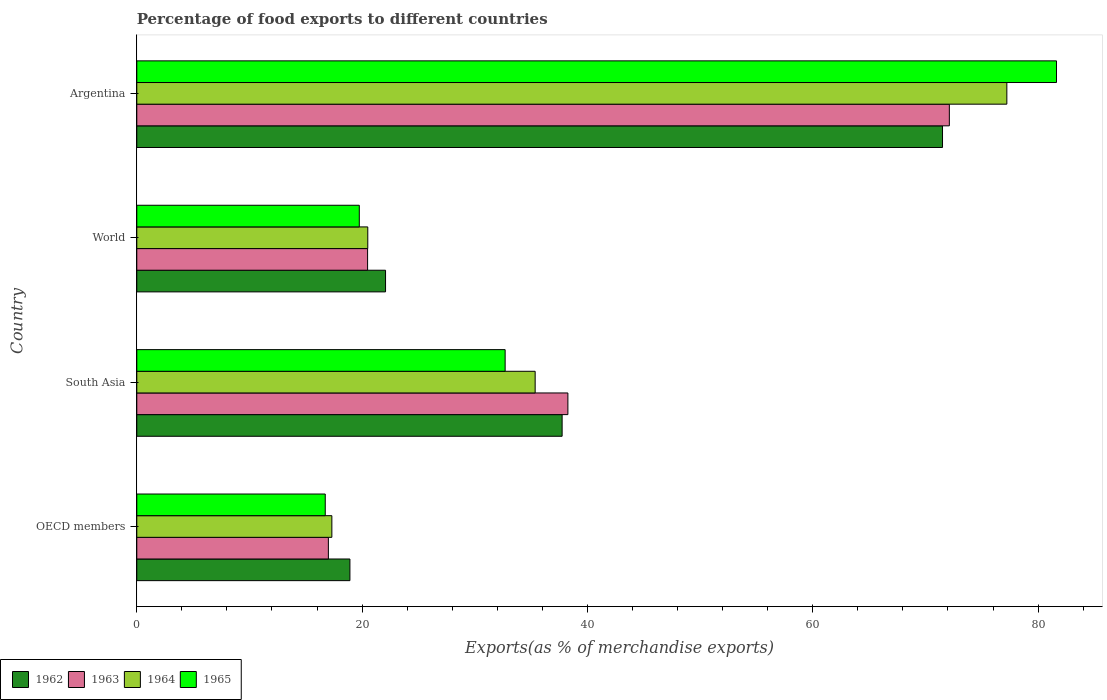Are the number of bars per tick equal to the number of legend labels?
Your response must be concise. Yes. Are the number of bars on each tick of the Y-axis equal?
Keep it short and to the point. Yes. How many bars are there on the 1st tick from the bottom?
Keep it short and to the point. 4. What is the label of the 1st group of bars from the top?
Your answer should be compact. Argentina. What is the percentage of exports to different countries in 1962 in OECD members?
Ensure brevity in your answer.  18.92. Across all countries, what is the maximum percentage of exports to different countries in 1962?
Your answer should be very brief. 71.52. Across all countries, what is the minimum percentage of exports to different countries in 1962?
Ensure brevity in your answer.  18.92. In which country was the percentage of exports to different countries in 1965 maximum?
Your answer should be compact. Argentina. In which country was the percentage of exports to different countries in 1965 minimum?
Provide a short and direct response. OECD members. What is the total percentage of exports to different countries in 1963 in the graph?
Your response must be concise. 147.88. What is the difference between the percentage of exports to different countries in 1963 in Argentina and that in OECD members?
Offer a terse response. 55.12. What is the difference between the percentage of exports to different countries in 1963 in South Asia and the percentage of exports to different countries in 1964 in World?
Make the answer very short. 17.76. What is the average percentage of exports to different countries in 1964 per country?
Provide a succinct answer. 37.6. What is the difference between the percentage of exports to different countries in 1965 and percentage of exports to different countries in 1962 in World?
Your answer should be very brief. -2.33. What is the ratio of the percentage of exports to different countries in 1962 in OECD members to that in World?
Give a very brief answer. 0.86. Is the percentage of exports to different countries in 1962 in OECD members less than that in World?
Your response must be concise. Yes. What is the difference between the highest and the second highest percentage of exports to different countries in 1962?
Provide a short and direct response. 33.76. What is the difference between the highest and the lowest percentage of exports to different countries in 1964?
Provide a short and direct response. 59.91. In how many countries, is the percentage of exports to different countries in 1964 greater than the average percentage of exports to different countries in 1964 taken over all countries?
Provide a short and direct response. 1. Is the sum of the percentage of exports to different countries in 1965 in Argentina and World greater than the maximum percentage of exports to different countries in 1964 across all countries?
Offer a terse response. Yes. What does the 2nd bar from the top in Argentina represents?
Provide a short and direct response. 1964. What does the 4th bar from the bottom in World represents?
Offer a terse response. 1965. Are all the bars in the graph horizontal?
Your answer should be compact. Yes. What is the difference between two consecutive major ticks on the X-axis?
Offer a terse response. 20. Are the values on the major ticks of X-axis written in scientific E-notation?
Make the answer very short. No. Does the graph contain any zero values?
Offer a very short reply. No. Does the graph contain grids?
Give a very brief answer. No. How many legend labels are there?
Your answer should be very brief. 4. How are the legend labels stacked?
Your answer should be compact. Horizontal. What is the title of the graph?
Offer a very short reply. Percentage of food exports to different countries. What is the label or title of the X-axis?
Offer a terse response. Exports(as % of merchandise exports). What is the label or title of the Y-axis?
Provide a short and direct response. Country. What is the Exports(as % of merchandise exports) in 1962 in OECD members?
Make the answer very short. 18.92. What is the Exports(as % of merchandise exports) of 1963 in OECD members?
Provide a short and direct response. 17.01. What is the Exports(as % of merchandise exports) in 1964 in OECD members?
Give a very brief answer. 17.31. What is the Exports(as % of merchandise exports) of 1965 in OECD members?
Provide a succinct answer. 16.73. What is the Exports(as % of merchandise exports) in 1962 in South Asia?
Give a very brief answer. 37.75. What is the Exports(as % of merchandise exports) of 1963 in South Asia?
Offer a terse response. 38.26. What is the Exports(as % of merchandise exports) in 1964 in South Asia?
Provide a succinct answer. 35.36. What is the Exports(as % of merchandise exports) of 1965 in South Asia?
Your response must be concise. 32.7. What is the Exports(as % of merchandise exports) in 1962 in World?
Offer a very short reply. 22.08. What is the Exports(as % of merchandise exports) in 1963 in World?
Your answer should be very brief. 20.49. What is the Exports(as % of merchandise exports) in 1964 in World?
Make the answer very short. 20.5. What is the Exports(as % of merchandise exports) in 1965 in World?
Provide a succinct answer. 19.75. What is the Exports(as % of merchandise exports) in 1962 in Argentina?
Provide a succinct answer. 71.52. What is the Exports(as % of merchandise exports) in 1963 in Argentina?
Keep it short and to the point. 72.12. What is the Exports(as % of merchandise exports) in 1964 in Argentina?
Keep it short and to the point. 77.23. What is the Exports(as % of merchandise exports) in 1965 in Argentina?
Give a very brief answer. 81.64. Across all countries, what is the maximum Exports(as % of merchandise exports) of 1962?
Offer a very short reply. 71.52. Across all countries, what is the maximum Exports(as % of merchandise exports) of 1963?
Provide a short and direct response. 72.12. Across all countries, what is the maximum Exports(as % of merchandise exports) in 1964?
Your response must be concise. 77.23. Across all countries, what is the maximum Exports(as % of merchandise exports) of 1965?
Your answer should be compact. 81.64. Across all countries, what is the minimum Exports(as % of merchandise exports) of 1962?
Your answer should be very brief. 18.92. Across all countries, what is the minimum Exports(as % of merchandise exports) of 1963?
Your answer should be compact. 17.01. Across all countries, what is the minimum Exports(as % of merchandise exports) of 1964?
Offer a terse response. 17.31. Across all countries, what is the minimum Exports(as % of merchandise exports) in 1965?
Your answer should be very brief. 16.73. What is the total Exports(as % of merchandise exports) of 1962 in the graph?
Keep it short and to the point. 150.27. What is the total Exports(as % of merchandise exports) of 1963 in the graph?
Keep it short and to the point. 147.88. What is the total Exports(as % of merchandise exports) of 1964 in the graph?
Your answer should be very brief. 150.4. What is the total Exports(as % of merchandise exports) of 1965 in the graph?
Make the answer very short. 150.81. What is the difference between the Exports(as % of merchandise exports) of 1962 in OECD members and that in South Asia?
Your answer should be very brief. -18.84. What is the difference between the Exports(as % of merchandise exports) in 1963 in OECD members and that in South Asia?
Keep it short and to the point. -21.26. What is the difference between the Exports(as % of merchandise exports) of 1964 in OECD members and that in South Asia?
Offer a terse response. -18.05. What is the difference between the Exports(as % of merchandise exports) in 1965 in OECD members and that in South Asia?
Offer a terse response. -15.97. What is the difference between the Exports(as % of merchandise exports) in 1962 in OECD members and that in World?
Your answer should be compact. -3.16. What is the difference between the Exports(as % of merchandise exports) in 1963 in OECD members and that in World?
Your answer should be very brief. -3.48. What is the difference between the Exports(as % of merchandise exports) in 1964 in OECD members and that in World?
Make the answer very short. -3.19. What is the difference between the Exports(as % of merchandise exports) in 1965 in OECD members and that in World?
Offer a very short reply. -3.02. What is the difference between the Exports(as % of merchandise exports) of 1962 in OECD members and that in Argentina?
Offer a very short reply. -52.6. What is the difference between the Exports(as % of merchandise exports) of 1963 in OECD members and that in Argentina?
Make the answer very short. -55.12. What is the difference between the Exports(as % of merchandise exports) of 1964 in OECD members and that in Argentina?
Your response must be concise. -59.91. What is the difference between the Exports(as % of merchandise exports) of 1965 in OECD members and that in Argentina?
Keep it short and to the point. -64.91. What is the difference between the Exports(as % of merchandise exports) of 1962 in South Asia and that in World?
Your answer should be very brief. 15.67. What is the difference between the Exports(as % of merchandise exports) in 1963 in South Asia and that in World?
Offer a terse response. 17.78. What is the difference between the Exports(as % of merchandise exports) in 1964 in South Asia and that in World?
Your answer should be very brief. 14.86. What is the difference between the Exports(as % of merchandise exports) in 1965 in South Asia and that in World?
Give a very brief answer. 12.95. What is the difference between the Exports(as % of merchandise exports) in 1962 in South Asia and that in Argentina?
Keep it short and to the point. -33.76. What is the difference between the Exports(as % of merchandise exports) of 1963 in South Asia and that in Argentina?
Offer a terse response. -33.86. What is the difference between the Exports(as % of merchandise exports) in 1964 in South Asia and that in Argentina?
Give a very brief answer. -41.87. What is the difference between the Exports(as % of merchandise exports) in 1965 in South Asia and that in Argentina?
Your response must be concise. -48.94. What is the difference between the Exports(as % of merchandise exports) of 1962 in World and that in Argentina?
Keep it short and to the point. -49.44. What is the difference between the Exports(as % of merchandise exports) in 1963 in World and that in Argentina?
Make the answer very short. -51.64. What is the difference between the Exports(as % of merchandise exports) of 1964 in World and that in Argentina?
Ensure brevity in your answer.  -56.72. What is the difference between the Exports(as % of merchandise exports) of 1965 in World and that in Argentina?
Your answer should be compact. -61.88. What is the difference between the Exports(as % of merchandise exports) of 1962 in OECD members and the Exports(as % of merchandise exports) of 1963 in South Asia?
Keep it short and to the point. -19.35. What is the difference between the Exports(as % of merchandise exports) in 1962 in OECD members and the Exports(as % of merchandise exports) in 1964 in South Asia?
Provide a short and direct response. -16.44. What is the difference between the Exports(as % of merchandise exports) of 1962 in OECD members and the Exports(as % of merchandise exports) of 1965 in South Asia?
Your answer should be compact. -13.78. What is the difference between the Exports(as % of merchandise exports) in 1963 in OECD members and the Exports(as % of merchandise exports) in 1964 in South Asia?
Make the answer very short. -18.35. What is the difference between the Exports(as % of merchandise exports) in 1963 in OECD members and the Exports(as % of merchandise exports) in 1965 in South Asia?
Offer a terse response. -15.69. What is the difference between the Exports(as % of merchandise exports) of 1964 in OECD members and the Exports(as % of merchandise exports) of 1965 in South Asia?
Your response must be concise. -15.38. What is the difference between the Exports(as % of merchandise exports) in 1962 in OECD members and the Exports(as % of merchandise exports) in 1963 in World?
Your response must be concise. -1.57. What is the difference between the Exports(as % of merchandise exports) of 1962 in OECD members and the Exports(as % of merchandise exports) of 1964 in World?
Provide a succinct answer. -1.59. What is the difference between the Exports(as % of merchandise exports) in 1962 in OECD members and the Exports(as % of merchandise exports) in 1965 in World?
Provide a short and direct response. -0.83. What is the difference between the Exports(as % of merchandise exports) of 1963 in OECD members and the Exports(as % of merchandise exports) of 1964 in World?
Provide a succinct answer. -3.5. What is the difference between the Exports(as % of merchandise exports) of 1963 in OECD members and the Exports(as % of merchandise exports) of 1965 in World?
Provide a short and direct response. -2.74. What is the difference between the Exports(as % of merchandise exports) of 1964 in OECD members and the Exports(as % of merchandise exports) of 1965 in World?
Give a very brief answer. -2.44. What is the difference between the Exports(as % of merchandise exports) in 1962 in OECD members and the Exports(as % of merchandise exports) in 1963 in Argentina?
Give a very brief answer. -53.21. What is the difference between the Exports(as % of merchandise exports) of 1962 in OECD members and the Exports(as % of merchandise exports) of 1964 in Argentina?
Your answer should be compact. -58.31. What is the difference between the Exports(as % of merchandise exports) in 1962 in OECD members and the Exports(as % of merchandise exports) in 1965 in Argentina?
Your answer should be very brief. -62.72. What is the difference between the Exports(as % of merchandise exports) of 1963 in OECD members and the Exports(as % of merchandise exports) of 1964 in Argentina?
Your answer should be very brief. -60.22. What is the difference between the Exports(as % of merchandise exports) in 1963 in OECD members and the Exports(as % of merchandise exports) in 1965 in Argentina?
Ensure brevity in your answer.  -64.63. What is the difference between the Exports(as % of merchandise exports) in 1964 in OECD members and the Exports(as % of merchandise exports) in 1965 in Argentina?
Offer a very short reply. -64.32. What is the difference between the Exports(as % of merchandise exports) in 1962 in South Asia and the Exports(as % of merchandise exports) in 1963 in World?
Provide a short and direct response. 17.27. What is the difference between the Exports(as % of merchandise exports) of 1962 in South Asia and the Exports(as % of merchandise exports) of 1964 in World?
Provide a succinct answer. 17.25. What is the difference between the Exports(as % of merchandise exports) in 1962 in South Asia and the Exports(as % of merchandise exports) in 1965 in World?
Provide a succinct answer. 18. What is the difference between the Exports(as % of merchandise exports) of 1963 in South Asia and the Exports(as % of merchandise exports) of 1964 in World?
Give a very brief answer. 17.76. What is the difference between the Exports(as % of merchandise exports) of 1963 in South Asia and the Exports(as % of merchandise exports) of 1965 in World?
Keep it short and to the point. 18.51. What is the difference between the Exports(as % of merchandise exports) in 1964 in South Asia and the Exports(as % of merchandise exports) in 1965 in World?
Make the answer very short. 15.61. What is the difference between the Exports(as % of merchandise exports) of 1962 in South Asia and the Exports(as % of merchandise exports) of 1963 in Argentina?
Make the answer very short. -34.37. What is the difference between the Exports(as % of merchandise exports) of 1962 in South Asia and the Exports(as % of merchandise exports) of 1964 in Argentina?
Provide a succinct answer. -39.47. What is the difference between the Exports(as % of merchandise exports) in 1962 in South Asia and the Exports(as % of merchandise exports) in 1965 in Argentina?
Ensure brevity in your answer.  -43.88. What is the difference between the Exports(as % of merchandise exports) in 1963 in South Asia and the Exports(as % of merchandise exports) in 1964 in Argentina?
Make the answer very short. -38.96. What is the difference between the Exports(as % of merchandise exports) of 1963 in South Asia and the Exports(as % of merchandise exports) of 1965 in Argentina?
Your answer should be very brief. -43.37. What is the difference between the Exports(as % of merchandise exports) of 1964 in South Asia and the Exports(as % of merchandise exports) of 1965 in Argentina?
Your answer should be very brief. -46.28. What is the difference between the Exports(as % of merchandise exports) in 1962 in World and the Exports(as % of merchandise exports) in 1963 in Argentina?
Give a very brief answer. -50.04. What is the difference between the Exports(as % of merchandise exports) in 1962 in World and the Exports(as % of merchandise exports) in 1964 in Argentina?
Ensure brevity in your answer.  -55.15. What is the difference between the Exports(as % of merchandise exports) of 1962 in World and the Exports(as % of merchandise exports) of 1965 in Argentina?
Give a very brief answer. -59.55. What is the difference between the Exports(as % of merchandise exports) in 1963 in World and the Exports(as % of merchandise exports) in 1964 in Argentina?
Your answer should be very brief. -56.74. What is the difference between the Exports(as % of merchandise exports) of 1963 in World and the Exports(as % of merchandise exports) of 1965 in Argentina?
Keep it short and to the point. -61.15. What is the difference between the Exports(as % of merchandise exports) in 1964 in World and the Exports(as % of merchandise exports) in 1965 in Argentina?
Your answer should be very brief. -61.13. What is the average Exports(as % of merchandise exports) of 1962 per country?
Give a very brief answer. 37.57. What is the average Exports(as % of merchandise exports) in 1963 per country?
Make the answer very short. 36.97. What is the average Exports(as % of merchandise exports) in 1964 per country?
Provide a short and direct response. 37.6. What is the average Exports(as % of merchandise exports) of 1965 per country?
Offer a terse response. 37.7. What is the difference between the Exports(as % of merchandise exports) of 1962 and Exports(as % of merchandise exports) of 1963 in OECD members?
Ensure brevity in your answer.  1.91. What is the difference between the Exports(as % of merchandise exports) of 1962 and Exports(as % of merchandise exports) of 1964 in OECD members?
Ensure brevity in your answer.  1.6. What is the difference between the Exports(as % of merchandise exports) of 1962 and Exports(as % of merchandise exports) of 1965 in OECD members?
Ensure brevity in your answer.  2.19. What is the difference between the Exports(as % of merchandise exports) of 1963 and Exports(as % of merchandise exports) of 1964 in OECD members?
Provide a succinct answer. -0.31. What is the difference between the Exports(as % of merchandise exports) in 1963 and Exports(as % of merchandise exports) in 1965 in OECD members?
Ensure brevity in your answer.  0.28. What is the difference between the Exports(as % of merchandise exports) of 1964 and Exports(as % of merchandise exports) of 1965 in OECD members?
Keep it short and to the point. 0.59. What is the difference between the Exports(as % of merchandise exports) of 1962 and Exports(as % of merchandise exports) of 1963 in South Asia?
Offer a terse response. -0.51. What is the difference between the Exports(as % of merchandise exports) in 1962 and Exports(as % of merchandise exports) in 1964 in South Asia?
Ensure brevity in your answer.  2.39. What is the difference between the Exports(as % of merchandise exports) of 1962 and Exports(as % of merchandise exports) of 1965 in South Asia?
Keep it short and to the point. 5.06. What is the difference between the Exports(as % of merchandise exports) in 1963 and Exports(as % of merchandise exports) in 1964 in South Asia?
Offer a very short reply. 2.9. What is the difference between the Exports(as % of merchandise exports) in 1963 and Exports(as % of merchandise exports) in 1965 in South Asia?
Keep it short and to the point. 5.57. What is the difference between the Exports(as % of merchandise exports) of 1964 and Exports(as % of merchandise exports) of 1965 in South Asia?
Keep it short and to the point. 2.66. What is the difference between the Exports(as % of merchandise exports) in 1962 and Exports(as % of merchandise exports) in 1963 in World?
Ensure brevity in your answer.  1.59. What is the difference between the Exports(as % of merchandise exports) of 1962 and Exports(as % of merchandise exports) of 1964 in World?
Your answer should be very brief. 1.58. What is the difference between the Exports(as % of merchandise exports) in 1962 and Exports(as % of merchandise exports) in 1965 in World?
Keep it short and to the point. 2.33. What is the difference between the Exports(as % of merchandise exports) of 1963 and Exports(as % of merchandise exports) of 1964 in World?
Make the answer very short. -0.02. What is the difference between the Exports(as % of merchandise exports) in 1963 and Exports(as % of merchandise exports) in 1965 in World?
Your answer should be very brief. 0.74. What is the difference between the Exports(as % of merchandise exports) of 1964 and Exports(as % of merchandise exports) of 1965 in World?
Offer a terse response. 0.75. What is the difference between the Exports(as % of merchandise exports) in 1962 and Exports(as % of merchandise exports) in 1963 in Argentina?
Provide a succinct answer. -0.61. What is the difference between the Exports(as % of merchandise exports) of 1962 and Exports(as % of merchandise exports) of 1964 in Argentina?
Offer a terse response. -5.71. What is the difference between the Exports(as % of merchandise exports) of 1962 and Exports(as % of merchandise exports) of 1965 in Argentina?
Give a very brief answer. -10.12. What is the difference between the Exports(as % of merchandise exports) of 1963 and Exports(as % of merchandise exports) of 1964 in Argentina?
Provide a short and direct response. -5.1. What is the difference between the Exports(as % of merchandise exports) in 1963 and Exports(as % of merchandise exports) in 1965 in Argentina?
Keep it short and to the point. -9.51. What is the difference between the Exports(as % of merchandise exports) of 1964 and Exports(as % of merchandise exports) of 1965 in Argentina?
Offer a terse response. -4.41. What is the ratio of the Exports(as % of merchandise exports) of 1962 in OECD members to that in South Asia?
Keep it short and to the point. 0.5. What is the ratio of the Exports(as % of merchandise exports) in 1963 in OECD members to that in South Asia?
Give a very brief answer. 0.44. What is the ratio of the Exports(as % of merchandise exports) of 1964 in OECD members to that in South Asia?
Provide a short and direct response. 0.49. What is the ratio of the Exports(as % of merchandise exports) in 1965 in OECD members to that in South Asia?
Keep it short and to the point. 0.51. What is the ratio of the Exports(as % of merchandise exports) in 1962 in OECD members to that in World?
Give a very brief answer. 0.86. What is the ratio of the Exports(as % of merchandise exports) in 1963 in OECD members to that in World?
Offer a terse response. 0.83. What is the ratio of the Exports(as % of merchandise exports) of 1964 in OECD members to that in World?
Offer a terse response. 0.84. What is the ratio of the Exports(as % of merchandise exports) in 1965 in OECD members to that in World?
Offer a terse response. 0.85. What is the ratio of the Exports(as % of merchandise exports) of 1962 in OECD members to that in Argentina?
Your answer should be compact. 0.26. What is the ratio of the Exports(as % of merchandise exports) of 1963 in OECD members to that in Argentina?
Your answer should be very brief. 0.24. What is the ratio of the Exports(as % of merchandise exports) in 1964 in OECD members to that in Argentina?
Your response must be concise. 0.22. What is the ratio of the Exports(as % of merchandise exports) in 1965 in OECD members to that in Argentina?
Make the answer very short. 0.2. What is the ratio of the Exports(as % of merchandise exports) of 1962 in South Asia to that in World?
Your answer should be very brief. 1.71. What is the ratio of the Exports(as % of merchandise exports) of 1963 in South Asia to that in World?
Ensure brevity in your answer.  1.87. What is the ratio of the Exports(as % of merchandise exports) of 1964 in South Asia to that in World?
Provide a succinct answer. 1.72. What is the ratio of the Exports(as % of merchandise exports) in 1965 in South Asia to that in World?
Your answer should be very brief. 1.66. What is the ratio of the Exports(as % of merchandise exports) of 1962 in South Asia to that in Argentina?
Ensure brevity in your answer.  0.53. What is the ratio of the Exports(as % of merchandise exports) in 1963 in South Asia to that in Argentina?
Offer a terse response. 0.53. What is the ratio of the Exports(as % of merchandise exports) of 1964 in South Asia to that in Argentina?
Your response must be concise. 0.46. What is the ratio of the Exports(as % of merchandise exports) of 1965 in South Asia to that in Argentina?
Provide a short and direct response. 0.4. What is the ratio of the Exports(as % of merchandise exports) in 1962 in World to that in Argentina?
Provide a short and direct response. 0.31. What is the ratio of the Exports(as % of merchandise exports) in 1963 in World to that in Argentina?
Ensure brevity in your answer.  0.28. What is the ratio of the Exports(as % of merchandise exports) in 1964 in World to that in Argentina?
Your answer should be compact. 0.27. What is the ratio of the Exports(as % of merchandise exports) in 1965 in World to that in Argentina?
Provide a short and direct response. 0.24. What is the difference between the highest and the second highest Exports(as % of merchandise exports) in 1962?
Keep it short and to the point. 33.76. What is the difference between the highest and the second highest Exports(as % of merchandise exports) of 1963?
Keep it short and to the point. 33.86. What is the difference between the highest and the second highest Exports(as % of merchandise exports) in 1964?
Your response must be concise. 41.87. What is the difference between the highest and the second highest Exports(as % of merchandise exports) of 1965?
Your answer should be compact. 48.94. What is the difference between the highest and the lowest Exports(as % of merchandise exports) in 1962?
Your response must be concise. 52.6. What is the difference between the highest and the lowest Exports(as % of merchandise exports) of 1963?
Give a very brief answer. 55.12. What is the difference between the highest and the lowest Exports(as % of merchandise exports) in 1964?
Your response must be concise. 59.91. What is the difference between the highest and the lowest Exports(as % of merchandise exports) of 1965?
Give a very brief answer. 64.91. 